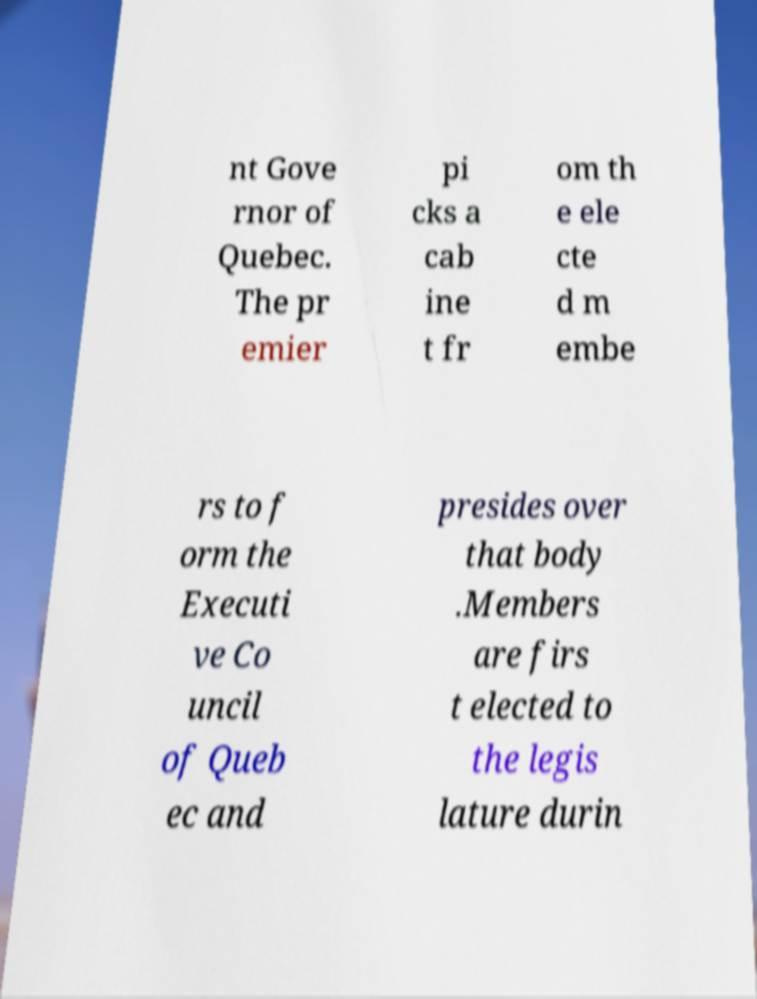What messages or text are displayed in this image? I need them in a readable, typed format. nt Gove rnor of Quebec. The pr emier pi cks a cab ine t fr om th e ele cte d m embe rs to f orm the Executi ve Co uncil of Queb ec and presides over that body .Members are firs t elected to the legis lature durin 